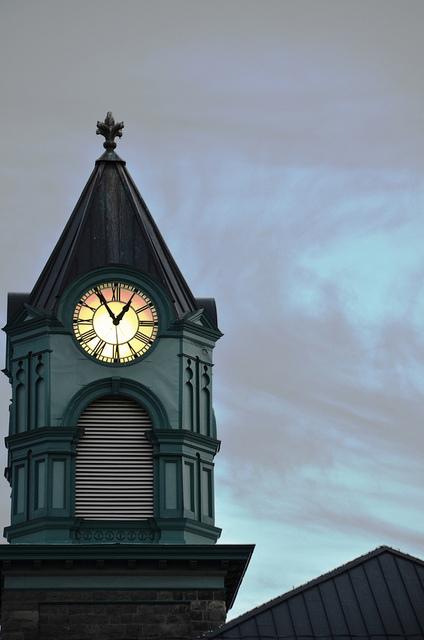Is the sun shining?
Write a very short answer. No. What color is the building?
Give a very brief answer. Green. What time is it?
Quick response, please. 12:55. What type of numbers are on the clock?
Write a very short answer. Roman numerals. What time is on the clock?
Be succinct. 12:55. Is there a light behind the clock?
Give a very brief answer. Yes. What time does it say on the clock?
Answer briefly. 12:55. What color is the tower?
Answer briefly. Green. 